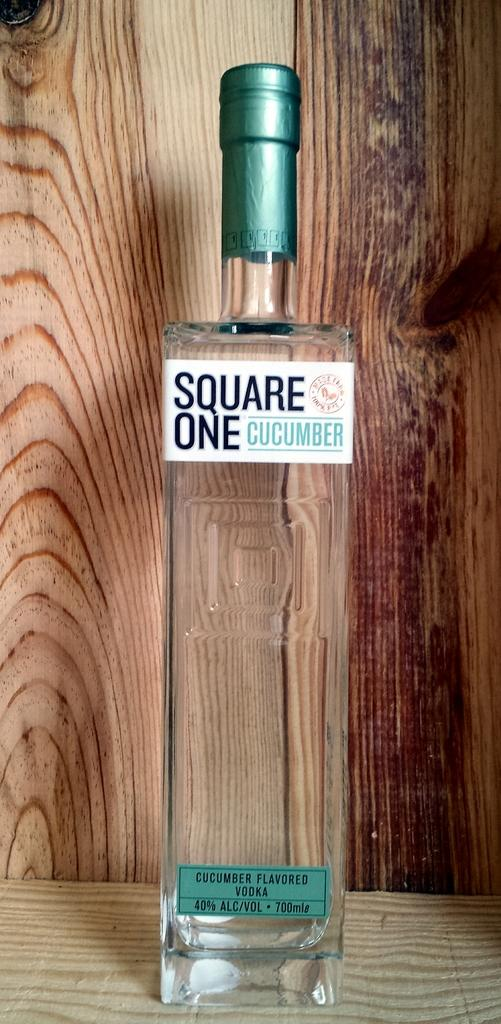<image>
Relay a brief, clear account of the picture shown. A bottle of Square One Cucumber Flavored Vodka stands inside a wooden crate. 